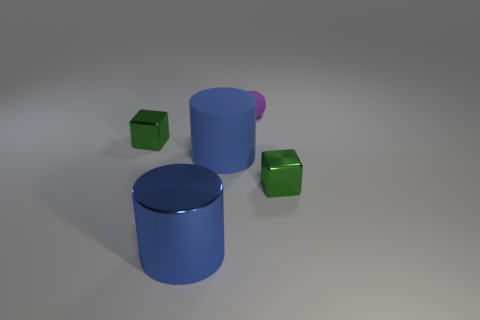There is a object that is the same color as the large shiny cylinder; what is its material?
Ensure brevity in your answer.  Rubber. The thing that is on the left side of the large metallic thing is what color?
Provide a succinct answer. Green. What material is the cylinder in front of the small green block that is right of the tiny purple object?
Your response must be concise. Metal. Is there a green cube of the same size as the purple matte sphere?
Keep it short and to the point. Yes. How many things are either green blocks that are to the left of the big metal cylinder or tiny purple spheres that are behind the large blue matte object?
Your answer should be compact. 2. There is a object that is on the right side of the purple rubber sphere; is it the same size as the green block that is to the left of the large blue metal cylinder?
Provide a succinct answer. Yes. There is a tiny green shiny object that is in front of the blue matte object; is there a sphere in front of it?
Ensure brevity in your answer.  No. There is a blue metallic cylinder; what number of tiny green things are right of it?
Offer a very short reply. 1. How many other things are there of the same color as the big matte cylinder?
Offer a very short reply. 1. Is the number of purple spheres behind the tiny purple thing less than the number of big blue things that are on the left side of the large blue matte object?
Your answer should be compact. Yes. 